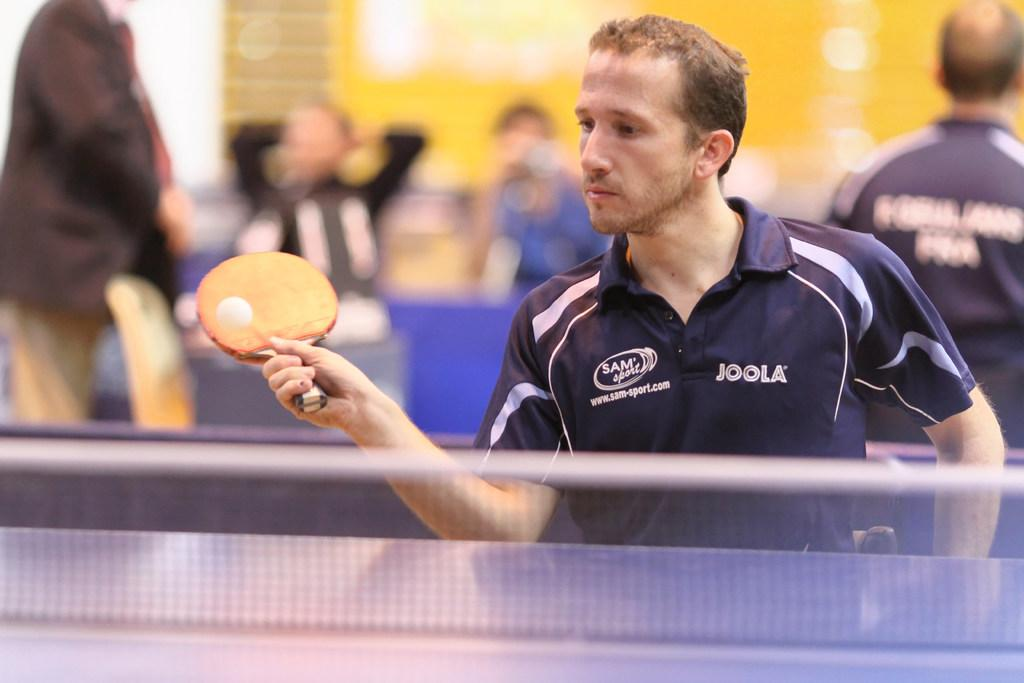<image>
Create a compact narrative representing the image presented. A man wearing a shirt that says Joola on it. 